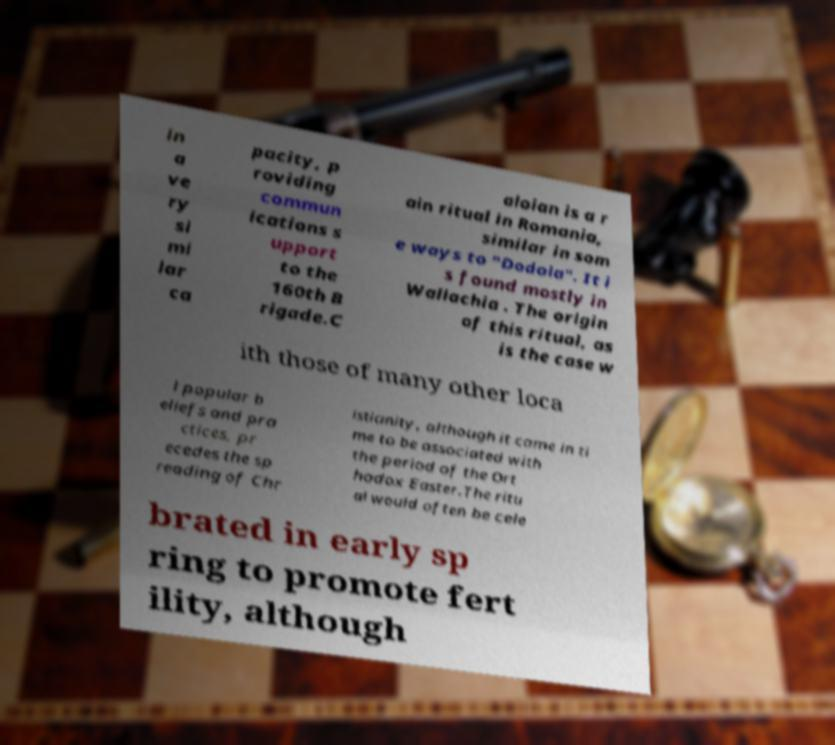I need the written content from this picture converted into text. Can you do that? in a ve ry si mi lar ca pacity, p roviding commun ications s upport to the 160th B rigade.C aloian is a r ain ritual in Romania, similar in som e ways to "Dodola". It i s found mostly in Wallachia . The origin of this ritual, as is the case w ith those of many other loca l popular b eliefs and pra ctices, pr ecedes the sp reading of Chr istianity, although it came in ti me to be associated with the period of the Ort hodox Easter.The ritu al would often be cele brated in early sp ring to promote fert ility, although 